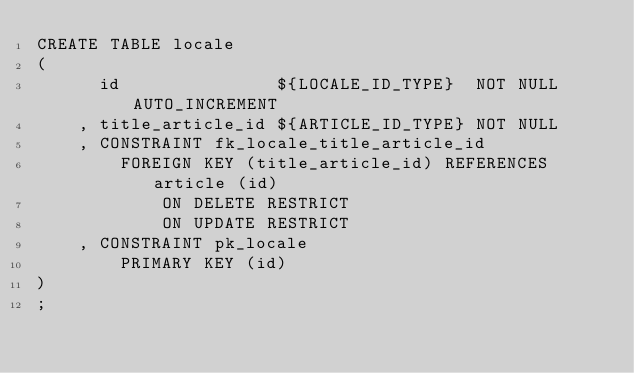Convert code to text. <code><loc_0><loc_0><loc_500><loc_500><_SQL_>CREATE TABLE locale
(
      id               ${LOCALE_ID_TYPE}  NOT NULL AUTO_INCREMENT
    , title_article_id ${ARTICLE_ID_TYPE} NOT NULL
    , CONSTRAINT fk_locale_title_article_id 
        FOREIGN KEY (title_article_id) REFERENCES article (id)
            ON DELETE RESTRICT
            ON UPDATE RESTRICT
    , CONSTRAINT pk_locale
        PRIMARY KEY (id)
)
;
</code> 